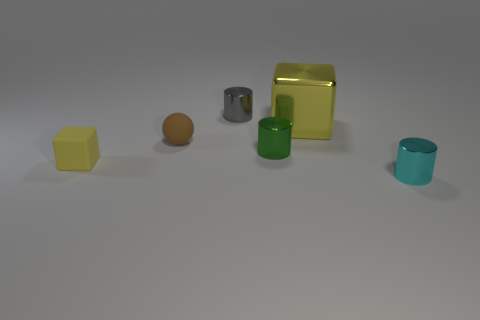Subtract all small green shiny cylinders. How many cylinders are left? 2 Subtract all spheres. How many objects are left? 5 Subtract 1 spheres. How many spheres are left? 0 Subtract all gray spheres. How many cyan cylinders are left? 1 Subtract all tiny yellow rubber blocks. Subtract all tiny blue shiny balls. How many objects are left? 5 Add 2 small cyan things. How many small cyan things are left? 3 Add 2 tiny shiny objects. How many tiny shiny objects exist? 5 Add 4 small blue balls. How many objects exist? 10 Subtract all cyan cylinders. How many cylinders are left? 2 Subtract 0 green balls. How many objects are left? 6 